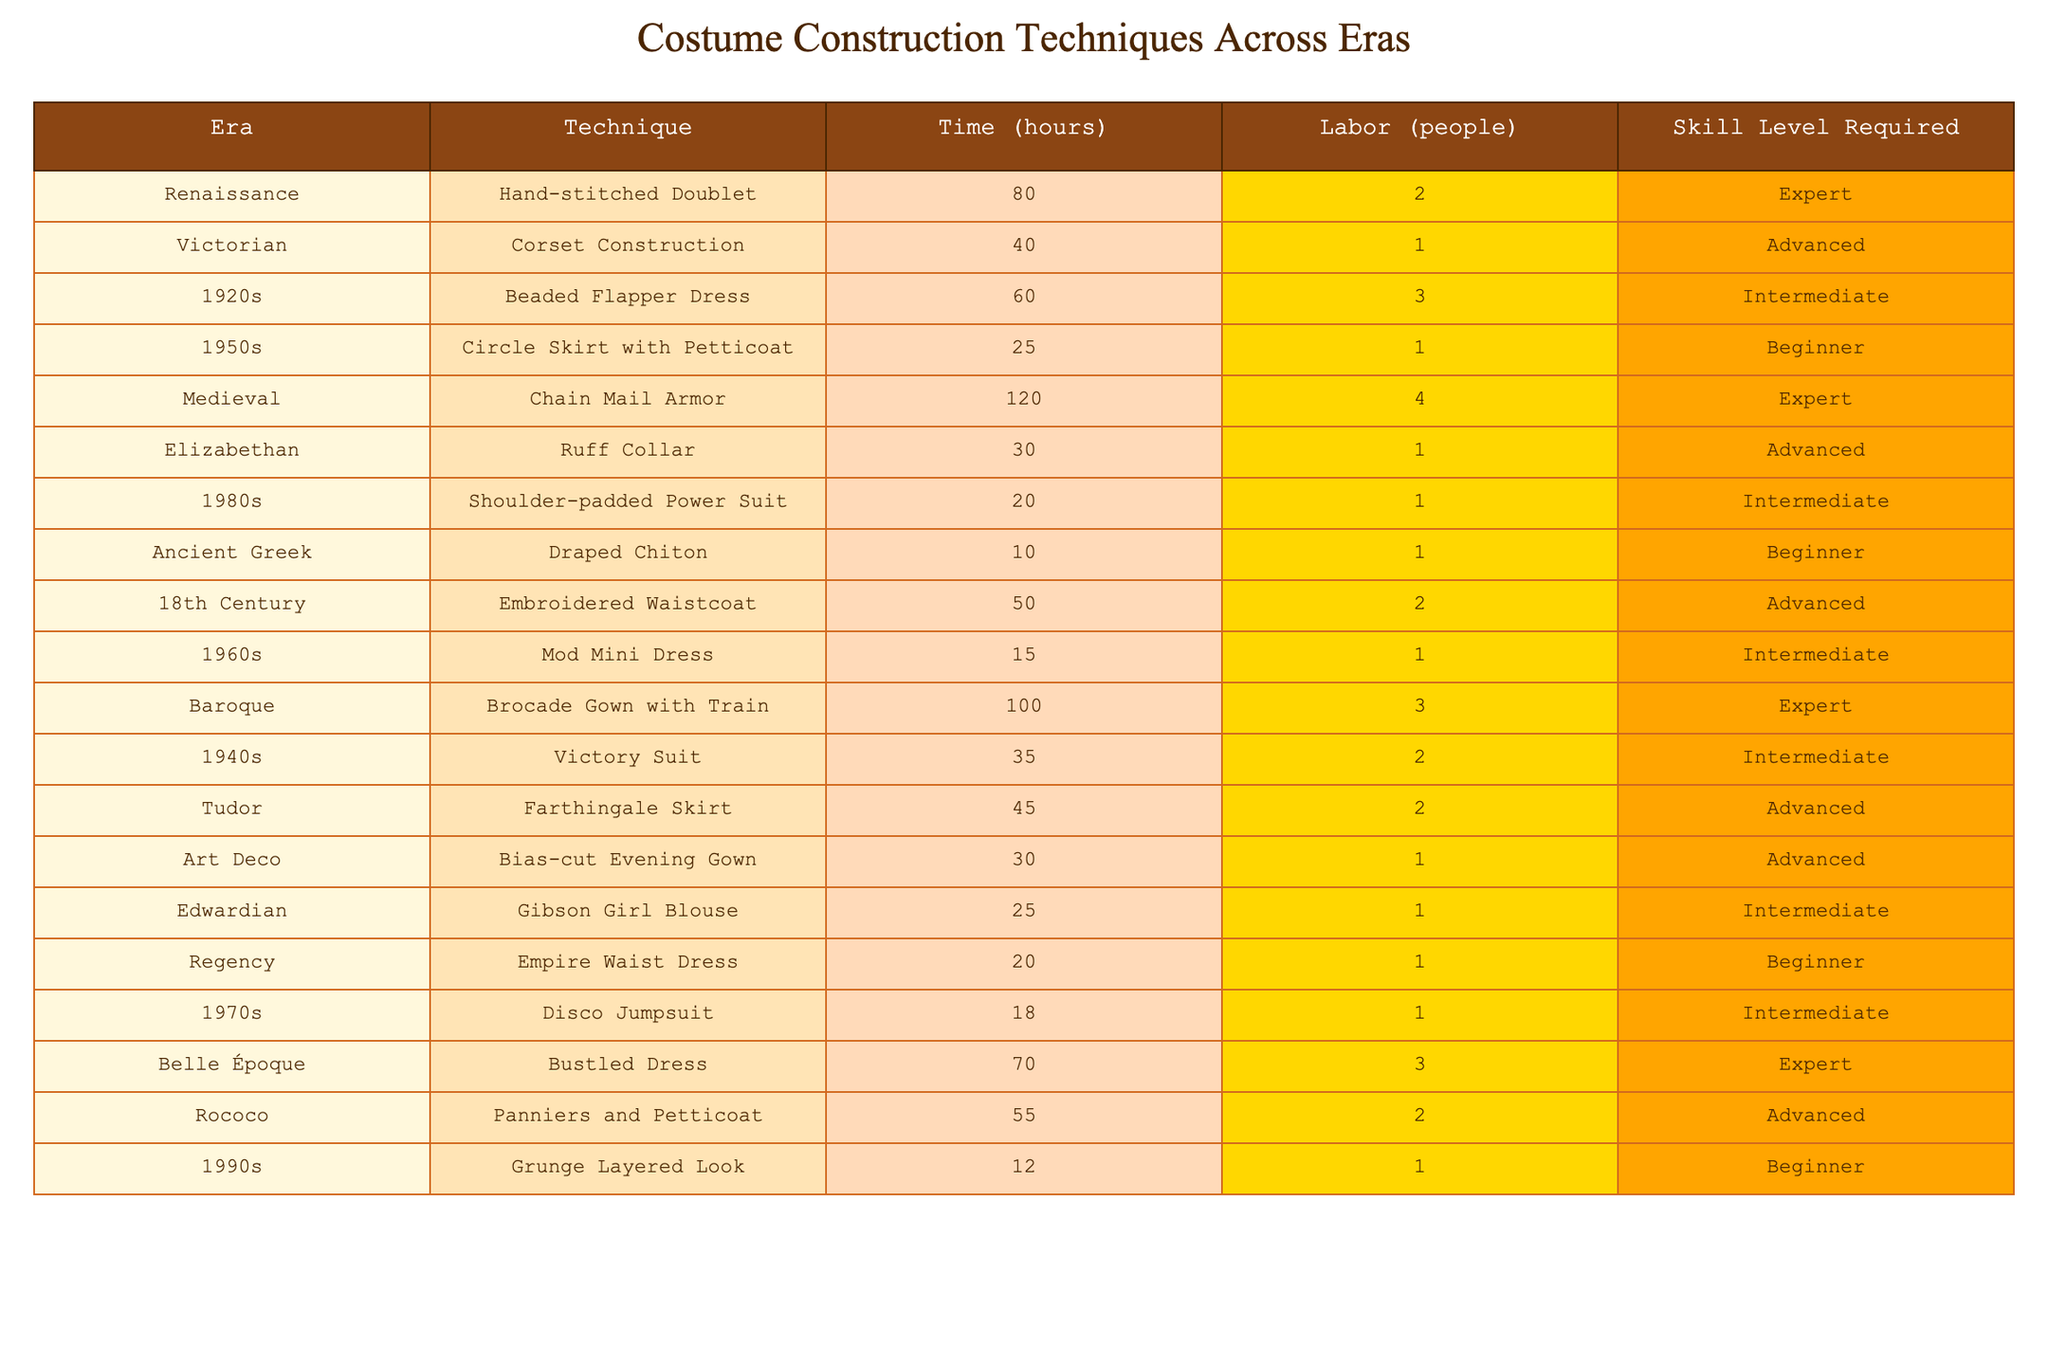What is the labor requirement for constructing a Chain Mail Armor? According to the table, the Chain Mail Armor requires 4 people for its construction.
Answer: 4 people Which technique requires the least amount of time for construction? The table shows that the Draped Chiton requires only 10 hours to construct, which is less than any other technique listed.
Answer: 10 hours What is the average time required for all techniques classified as "Intermediate"? The techniques classified as Intermediate are the Beaded Flapper Dress (60 hours), Shoulder-padded Power Suit (20 hours), Mod Mini Dress (15 hours), Victory Suit (35 hours), Gibson Girl Blouse (25 hours), Disco Jumpsuit (18 hours). Summing these gives 60 + 20 + 15 + 35 + 25 + 18 = 173 hours. Dividing by the number of techniques (6), the average time is 173/6 = approximately 28.83 hours.
Answer: 28.83 hours Is it true that all techniques from the Renaissance era require more than 70 hours to complete? In the table, the Hand-stitched Doublet from the Renaissance era requires 80 hours, which is more than 70. However, it is the only technique listed from this era, making the statement true.
Answer: Yes What is the difference in required labor between the Chain Mail Armor and the Circle Skirt with Petticoat? The Chain Mail Armor requires 4 people while the Circle Skirt with Petticoat requires only 1 person. The difference in labor required is 4 - 1 = 3 people.
Answer: 3 people Which era features the most labor-intensive technique and how many people are needed? The table indicates that the Chain Mail Armor techniques from the Medieval era requires the most labor, with 4 people needed for its construction.
Answer: 4 people How many techniques require an advanced skill level? The techniques requiring an advanced skill level are Corset Construction, Ruff Collar, Embroidered Waistcoat, Tudor Farthingale Skirt, Bias-cut Evening Gown, and Panniers and Petticoat. Counting these gives 5 techniques that require an advanced skill level.
Answer: 5 techniques What is the skill level required for the Draped Chiton? The Draped Chiton technique requires a beginner skill level, which is stated clearly in the table.
Answer: Beginner If you were to construct all techniques from the 1950s, how much total time would be spent? The techniques from the 1950s are Circle Skirt with Petticoat (25 hours) and the Shoulder-padded Power Suit (20 hours). Summing these: 25 + 20 = 45 hours.
Answer: 45 hours Is there any technique listed that requires only one person regardless of the era? Yes, the table lists several techniques that require only one person, including Circle Skirt with Petticoat, Corset Construction, Draped Chiton, and others.
Answer: Yes 